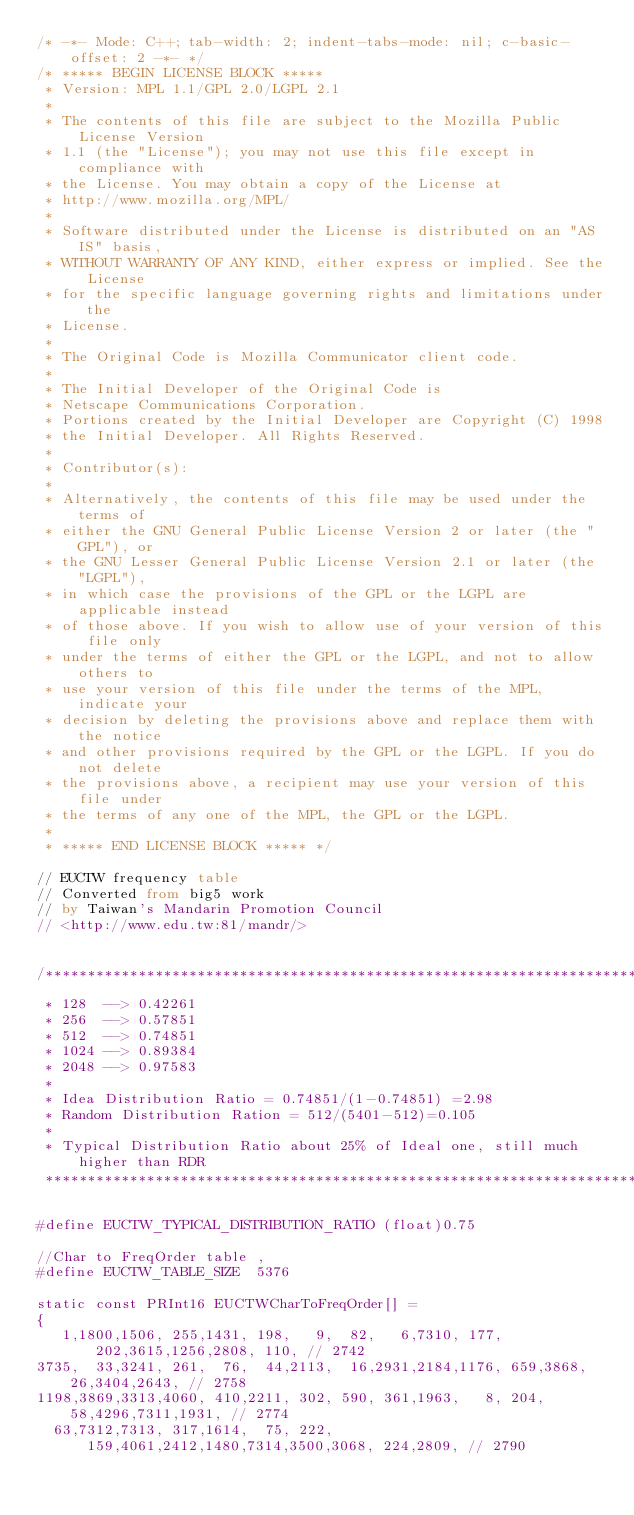<code> <loc_0><loc_0><loc_500><loc_500><_SQL_>/* -*- Mode: C++; tab-width: 2; indent-tabs-mode: nil; c-basic-offset: 2 -*- */
/* ***** BEGIN LICENSE BLOCK *****
 * Version: MPL 1.1/GPL 2.0/LGPL 2.1
 *
 * The contents of this file are subject to the Mozilla Public License Version
 * 1.1 (the "License"); you may not use this file except in compliance with
 * the License. You may obtain a copy of the License at
 * http://www.mozilla.org/MPL/
 *
 * Software distributed under the License is distributed on an "AS IS" basis,
 * WITHOUT WARRANTY OF ANY KIND, either express or implied. See the License
 * for the specific language governing rights and limitations under the
 * License.
 *
 * The Original Code is Mozilla Communicator client code.
 *
 * The Initial Developer of the Original Code is
 * Netscape Communications Corporation.
 * Portions created by the Initial Developer are Copyright (C) 1998
 * the Initial Developer. All Rights Reserved.
 *
 * Contributor(s):
 *
 * Alternatively, the contents of this file may be used under the terms of
 * either the GNU General Public License Version 2 or later (the "GPL"), or
 * the GNU Lesser General Public License Version 2.1 or later (the "LGPL"),
 * in which case the provisions of the GPL or the LGPL are applicable instead
 * of those above. If you wish to allow use of your version of this file only
 * under the terms of either the GPL or the LGPL, and not to allow others to
 * use your version of this file under the terms of the MPL, indicate your
 * decision by deleting the provisions above and replace them with the notice
 * and other provisions required by the GPL or the LGPL. If you do not delete
 * the provisions above, a recipient may use your version of this file under
 * the terms of any one of the MPL, the GPL or the LGPL.
 *
 * ***** END LICENSE BLOCK ***** */

// EUCTW frequency table
// Converted from big5 work 
// by Taiwan's Mandarin Promotion Council 
// <http://www.edu.tw:81/mandr/>


/******************************************************************************
 * 128  --> 0.42261
 * 256  --> 0.57851
 * 512  --> 0.74851
 * 1024 --> 0.89384
 * 2048 --> 0.97583
 *
 * Idea Distribution Ratio = 0.74851/(1-0.74851) =2.98
 * Random Distribution Ration = 512/(5401-512)=0.105
 * 
 * Typical Distribution Ratio about 25% of Ideal one, still much higher than RDR
 *****************************************************************************/

#define EUCTW_TYPICAL_DISTRIBUTION_RATIO (float)0.75

//Char to FreqOrder table , 
#define EUCTW_TABLE_SIZE  5376

static const PRInt16 EUCTWCharToFreqOrder[] =
{
   1,1800,1506, 255,1431, 198,   9,  82,   6,7310, 177, 202,3615,1256,2808, 110, // 2742
3735,  33,3241, 261,  76,  44,2113,  16,2931,2184,1176, 659,3868,  26,3404,2643, // 2758
1198,3869,3313,4060, 410,2211, 302, 590, 361,1963,   8, 204,  58,4296,7311,1931, // 2774
  63,7312,7313, 317,1614,  75, 222, 159,4061,2412,1480,7314,3500,3068, 224,2809, // 2790</code> 